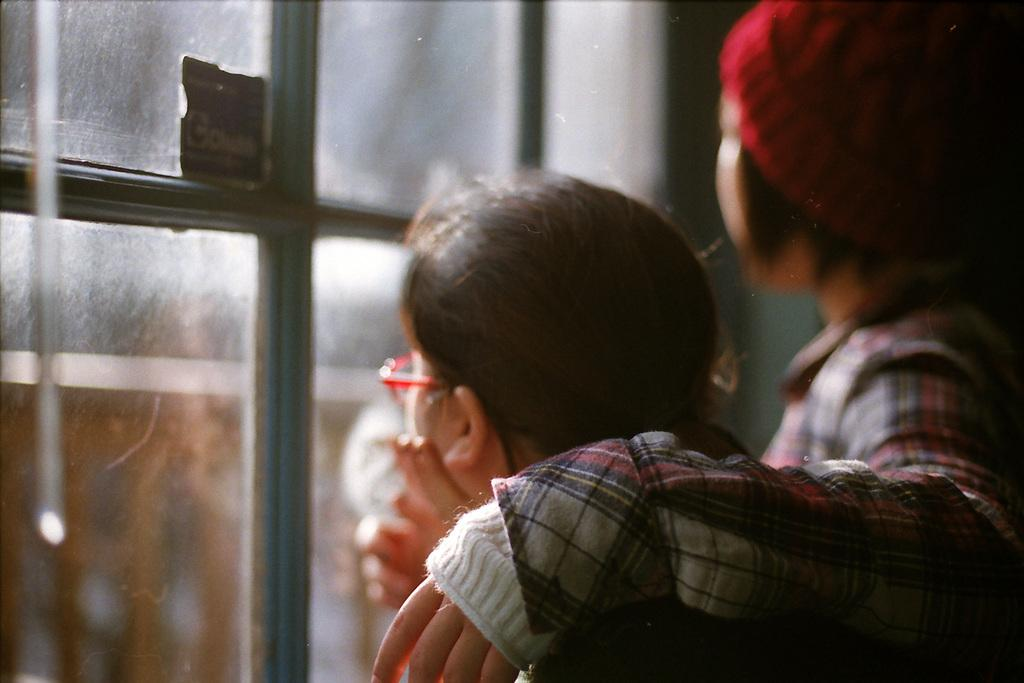How many people are in the image? There are two people in the image. What are the people doing in the image? The two people are standing. Can you describe any architectural features in the image? There is a glass window in the image. What type of quilt is being used to frame the stranger in the image? There is no quilt or stranger present in the image; it only features two people standing and a glass window. 